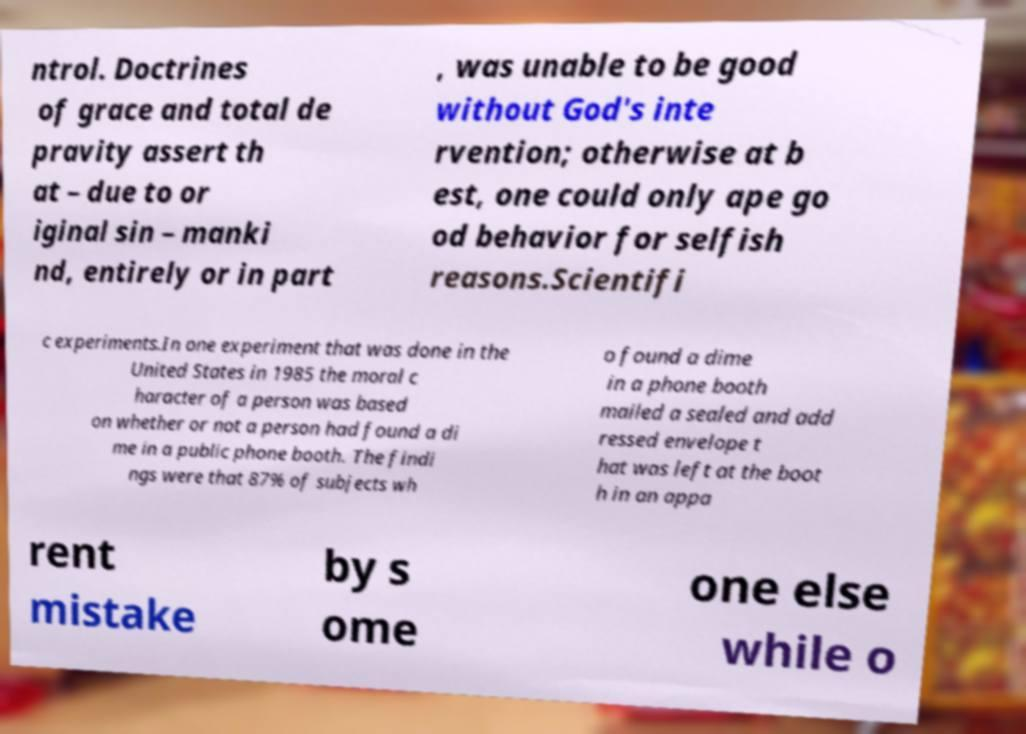Can you read and provide the text displayed in the image?This photo seems to have some interesting text. Can you extract and type it out for me? ntrol. Doctrines of grace and total de pravity assert th at – due to or iginal sin – manki nd, entirely or in part , was unable to be good without God's inte rvention; otherwise at b est, one could only ape go od behavior for selfish reasons.Scientifi c experiments.In one experiment that was done in the United States in 1985 the moral c haracter of a person was based on whether or not a person had found a di me in a public phone booth. The findi ngs were that 87% of subjects wh o found a dime in a phone booth mailed a sealed and add ressed envelope t hat was left at the boot h in an appa rent mistake by s ome one else while o 